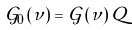<formula> <loc_0><loc_0><loc_500><loc_500>\mathcal { G } _ { 0 } \left ( \nu \right ) = \mathcal { G } \left ( \nu \right ) Q</formula> 